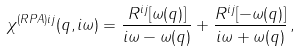<formula> <loc_0><loc_0><loc_500><loc_500>\chi ^ { ( R P A ) i j } ( { q } , i \omega ) = \frac { R ^ { i j } [ \omega ( { q } ) ] } { i \omega - \omega ( { q } ) } + \frac { R ^ { i j } [ - \omega ( { q } ) ] } { i \omega + \omega ( { q } ) } \, ,</formula> 